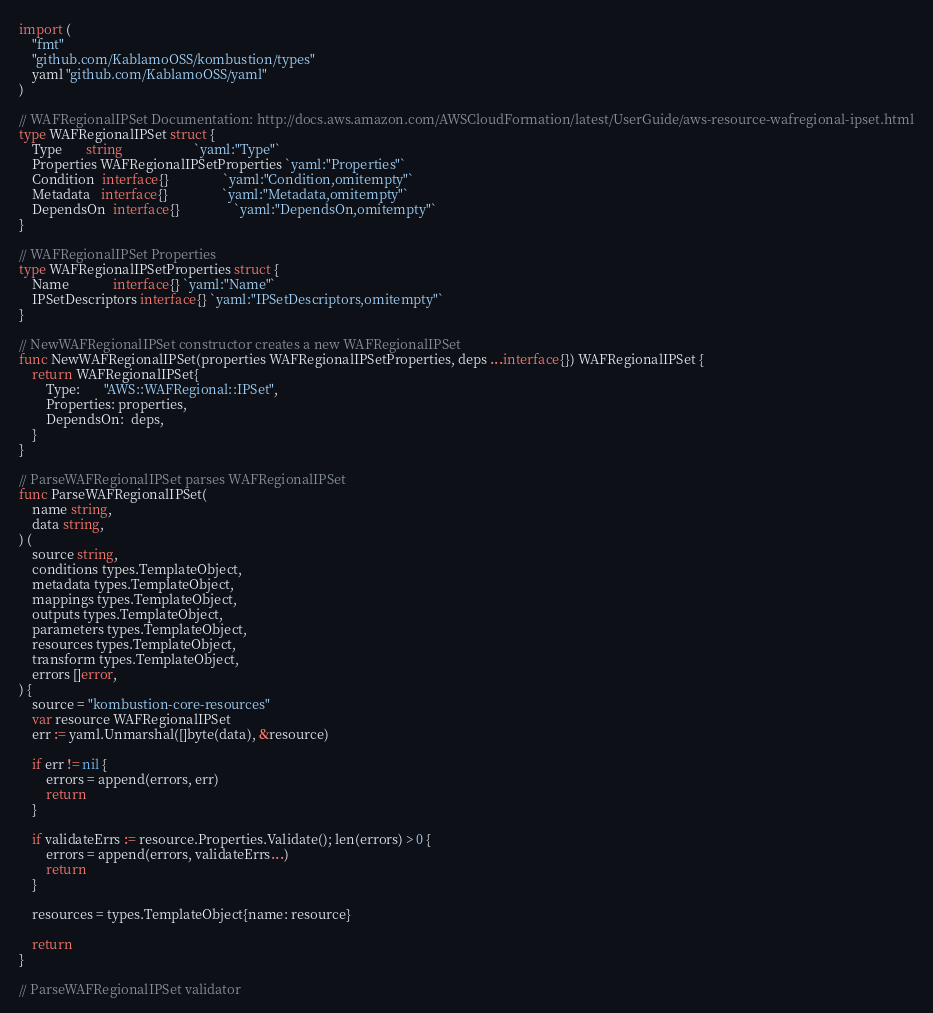<code> <loc_0><loc_0><loc_500><loc_500><_Go_>import (
	"fmt"
	"github.com/KablamoOSS/kombustion/types"
	yaml "github.com/KablamoOSS/yaml"
)

// WAFRegionalIPSet Documentation: http://docs.aws.amazon.com/AWSCloudFormation/latest/UserGuide/aws-resource-wafregional-ipset.html
type WAFRegionalIPSet struct {
	Type       string                     `yaml:"Type"`
	Properties WAFRegionalIPSetProperties `yaml:"Properties"`
	Condition  interface{}                `yaml:"Condition,omitempty"`
	Metadata   interface{}                `yaml:"Metadata,omitempty"`
	DependsOn  interface{}                `yaml:"DependsOn,omitempty"`
}

// WAFRegionalIPSet Properties
type WAFRegionalIPSetProperties struct {
	Name             interface{} `yaml:"Name"`
	IPSetDescriptors interface{} `yaml:"IPSetDescriptors,omitempty"`
}

// NewWAFRegionalIPSet constructor creates a new WAFRegionalIPSet
func NewWAFRegionalIPSet(properties WAFRegionalIPSetProperties, deps ...interface{}) WAFRegionalIPSet {
	return WAFRegionalIPSet{
		Type:       "AWS::WAFRegional::IPSet",
		Properties: properties,
		DependsOn:  deps,
	}
}

// ParseWAFRegionalIPSet parses WAFRegionalIPSet
func ParseWAFRegionalIPSet(
	name string,
	data string,
) (
	source string,
	conditions types.TemplateObject,
	metadata types.TemplateObject,
	mappings types.TemplateObject,
	outputs types.TemplateObject,
	parameters types.TemplateObject,
	resources types.TemplateObject,
	transform types.TemplateObject,
	errors []error,
) {
	source = "kombustion-core-resources"
	var resource WAFRegionalIPSet
	err := yaml.Unmarshal([]byte(data), &resource)

	if err != nil {
		errors = append(errors, err)
		return
	}

	if validateErrs := resource.Properties.Validate(); len(errors) > 0 {
		errors = append(errors, validateErrs...)
		return
	}

	resources = types.TemplateObject{name: resource}

	return
}

// ParseWAFRegionalIPSet validator</code> 